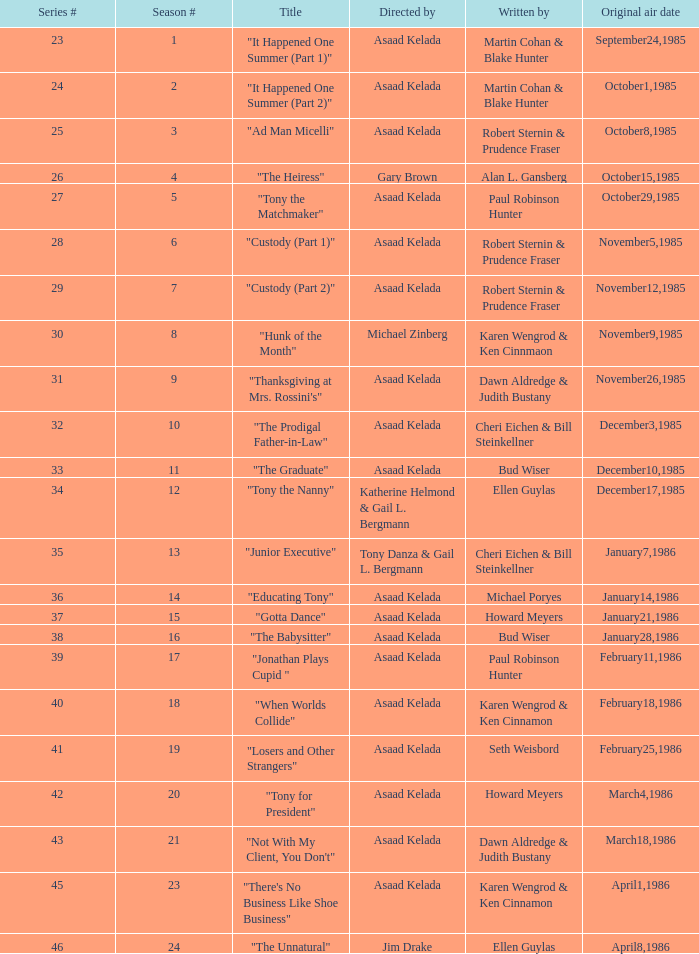Which season showcases author michael poryes? 14.0. 